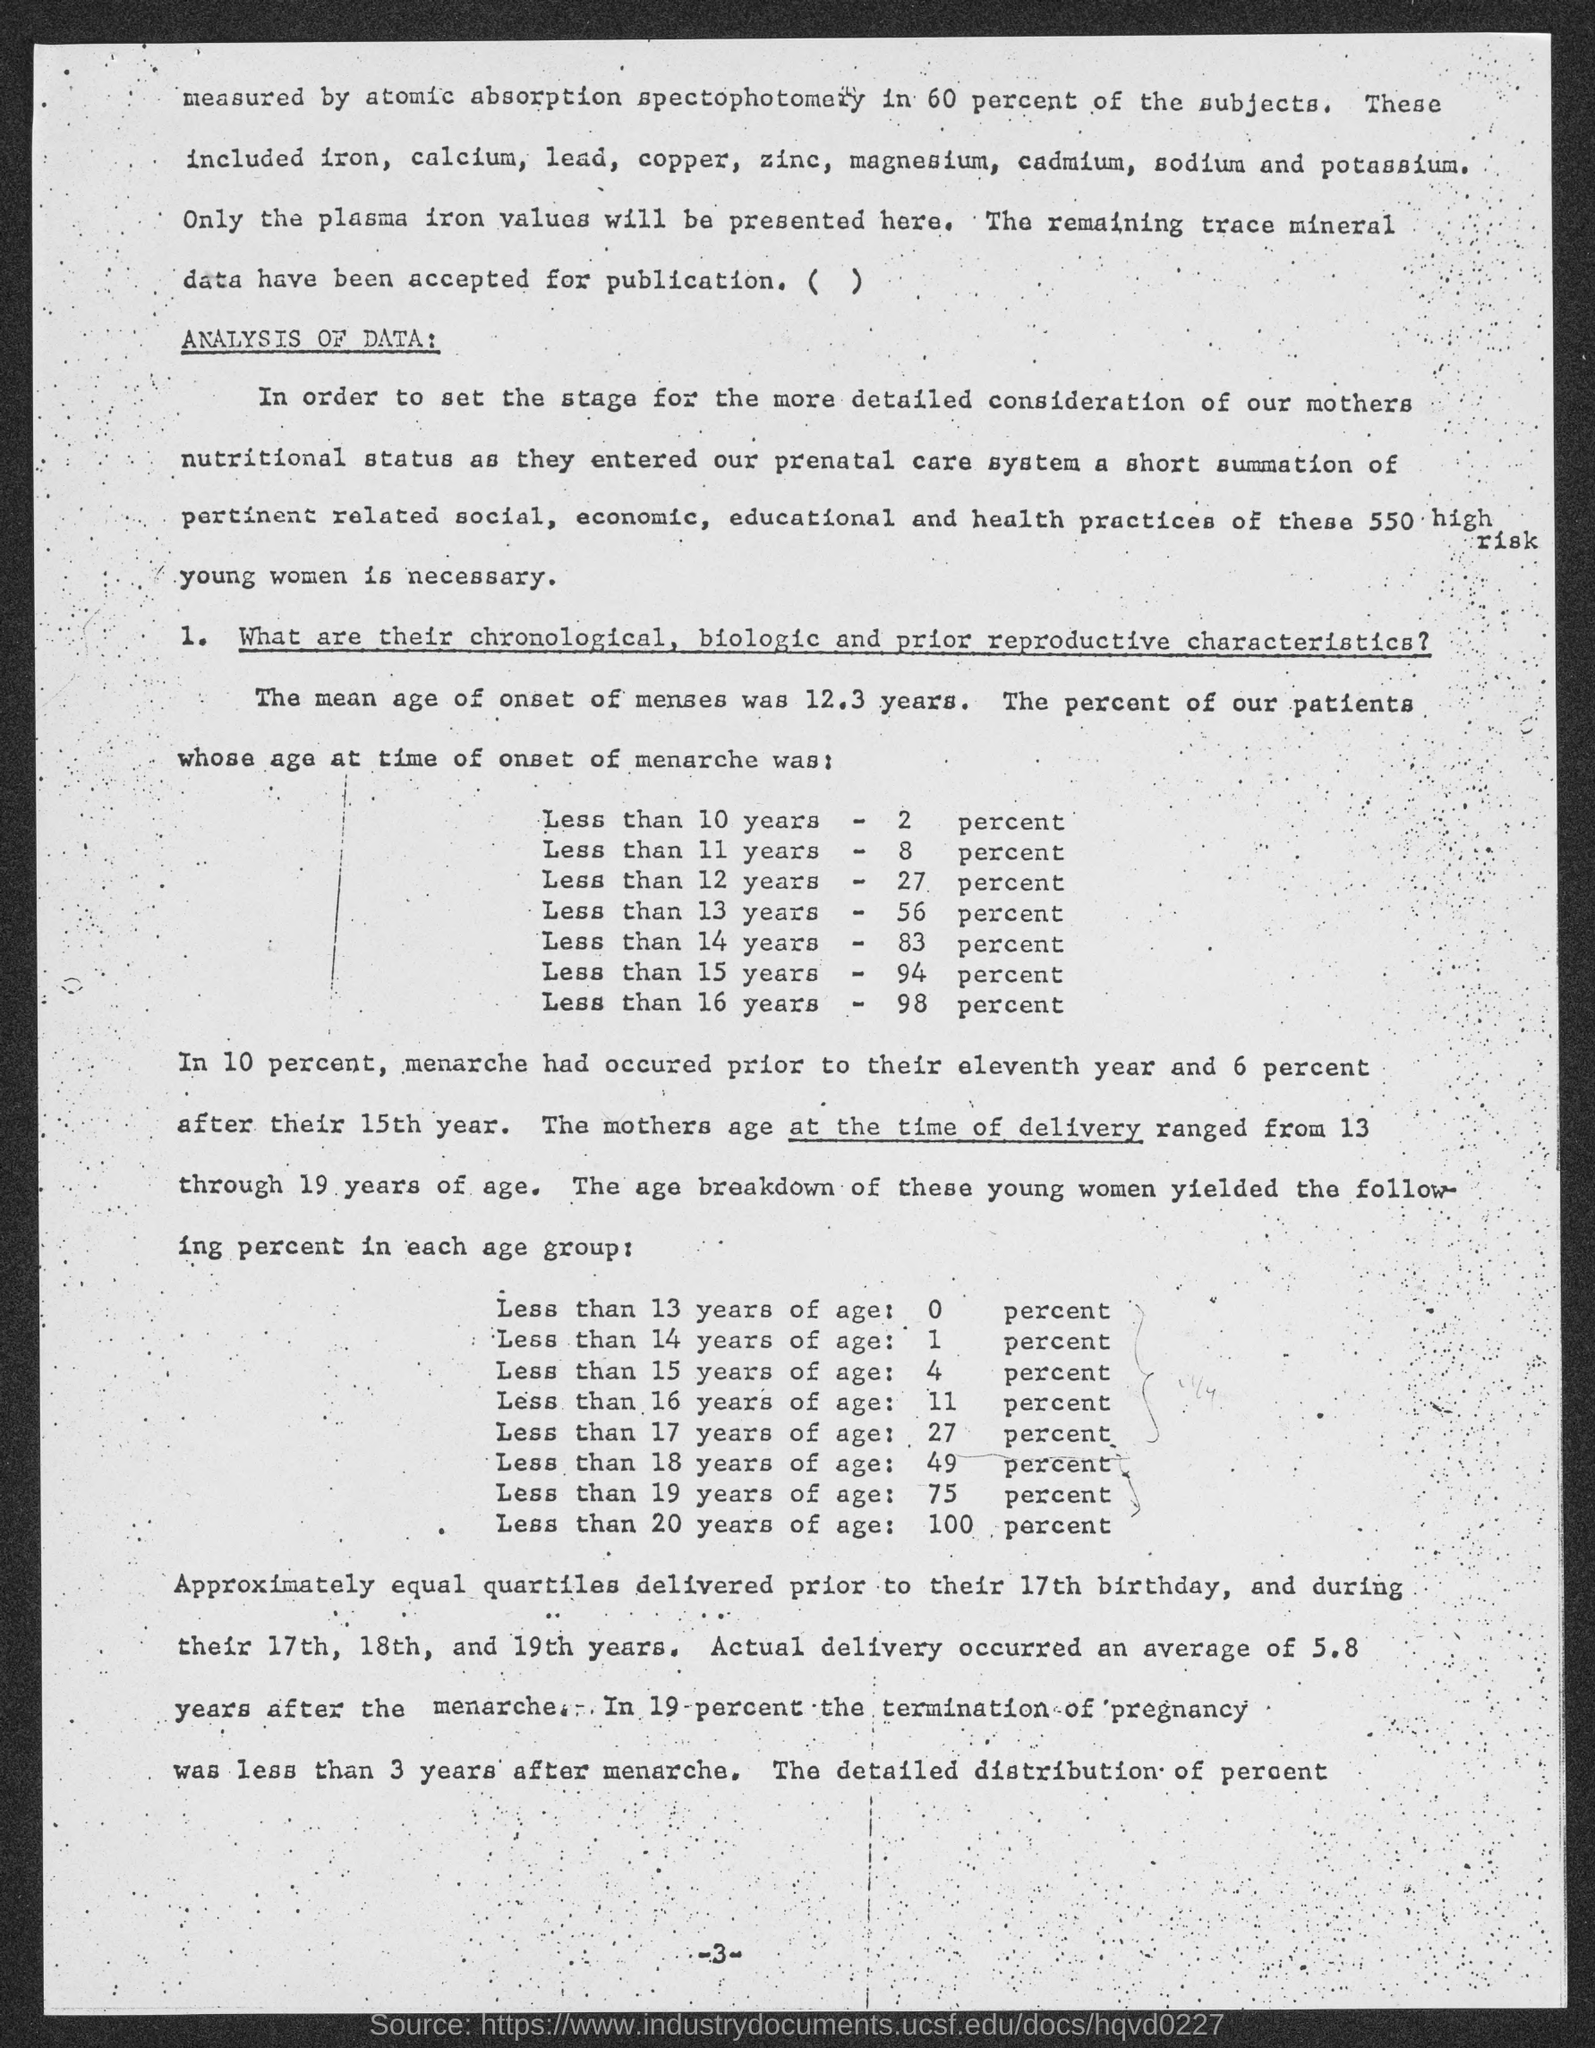What is the mean age of onset of menses?
Offer a very short reply. 12.3 years. What is the percent of patients whose age at the time of onset of menses was less than 10 years?
Offer a very short reply. 2 percent. What is the percent of patients whose age at the time of onset of menses was less than 11 years?
Give a very brief answer. 8 percent. What is the percent of patients whose age at the time of onset of menses was less than 12 years?
Your response must be concise. 27 percent. What is the percent of patients whose age at the time of onset of menses was less than 13 years?
Your answer should be very brief. 56 percent. What is the percent of patients whose age at the time of onset of menses was less than 14 years?
Offer a very short reply. 83 percent. What is the percent of patients whose age at the time of onset of menses was less than 15 years?
Offer a terse response. 94 percent. What is the percent of patients whose age at the time of onset of menses was less than 16 years?
Make the answer very short. 98 percent. 